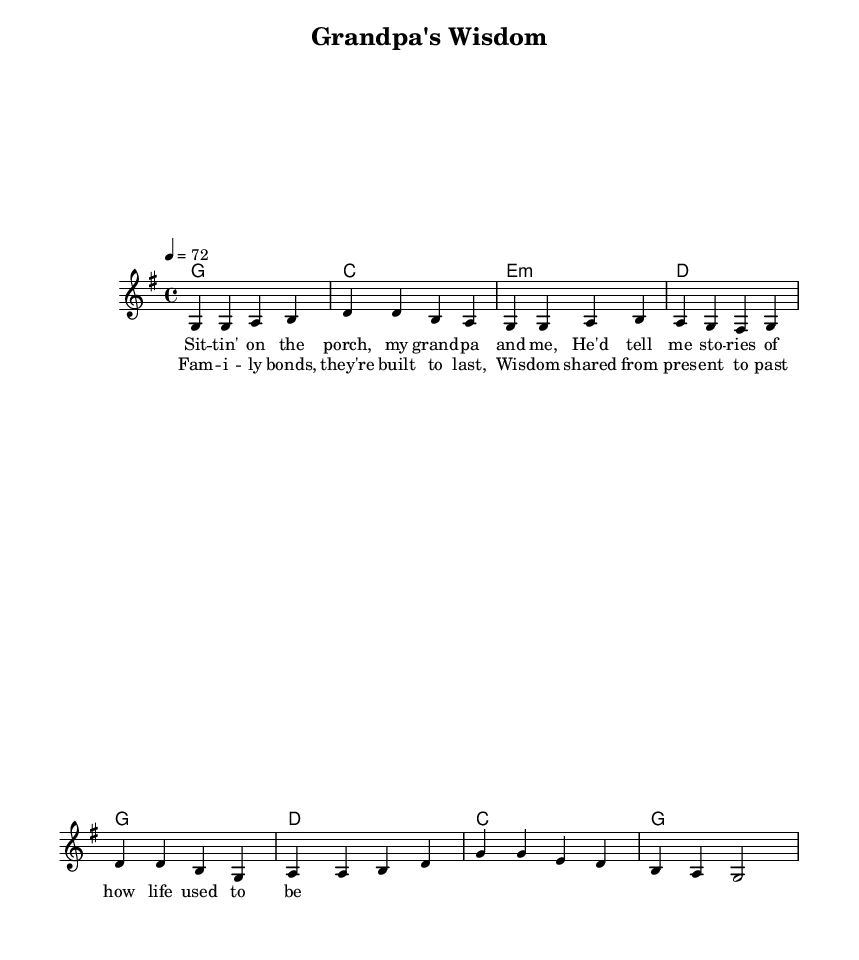What is the key signature of this music? The key signature appears at the beginning of the score, indicated by the presence of one sharp. Since it is set in G major, the key signature corresponds to G major, which has one sharp (F#).
Answer: G major What is the time signature of this music? The time signature is located right after the key signature at the beginning of the sheet music. In this case, it is marked with a "4/4", which indicates four beats in a measure, and each quarter note gets one beat.
Answer: 4/4 What is the tempo marking of this music? The tempo marking is shown at the beginning of the score, indicated by the text "4 = 72". This means that the quarter note is to be played at a speed of seventy-two beats per minute.
Answer: 72 How many measures are in the verse section of the song? To determine the number of measures in the verse section, we can count the number of measures written out for the verse music. In this score, there are four measures labeled for the verse section.
Answer: 4 What are the primary themes represented in the lyrics of this song? By examining the lyrics, we can identify key phrases that reflect overarching themes. In this song, the lyrics focus on the deep connection of family and the wisdom shared through generations, as evidenced in phrases like "family bonds" and "wisdom shared".
Answer: Family bonds and wisdom What chord follows the first measure of the chorus section? The chorus begins with a chord marking and in the first measure of the chorus, the chord indicated is G, as shown in the chord progression that accompanies the melody.
Answer: G What is the overall structural format of this piece? The structure of the piece can be determined by looking at the ordering of the music and lyrics. It follows a common format of a verse followed by a chorus. The verse is presented first, followed by the chorus as the repeated section.
Answer: Verse, Chorus 